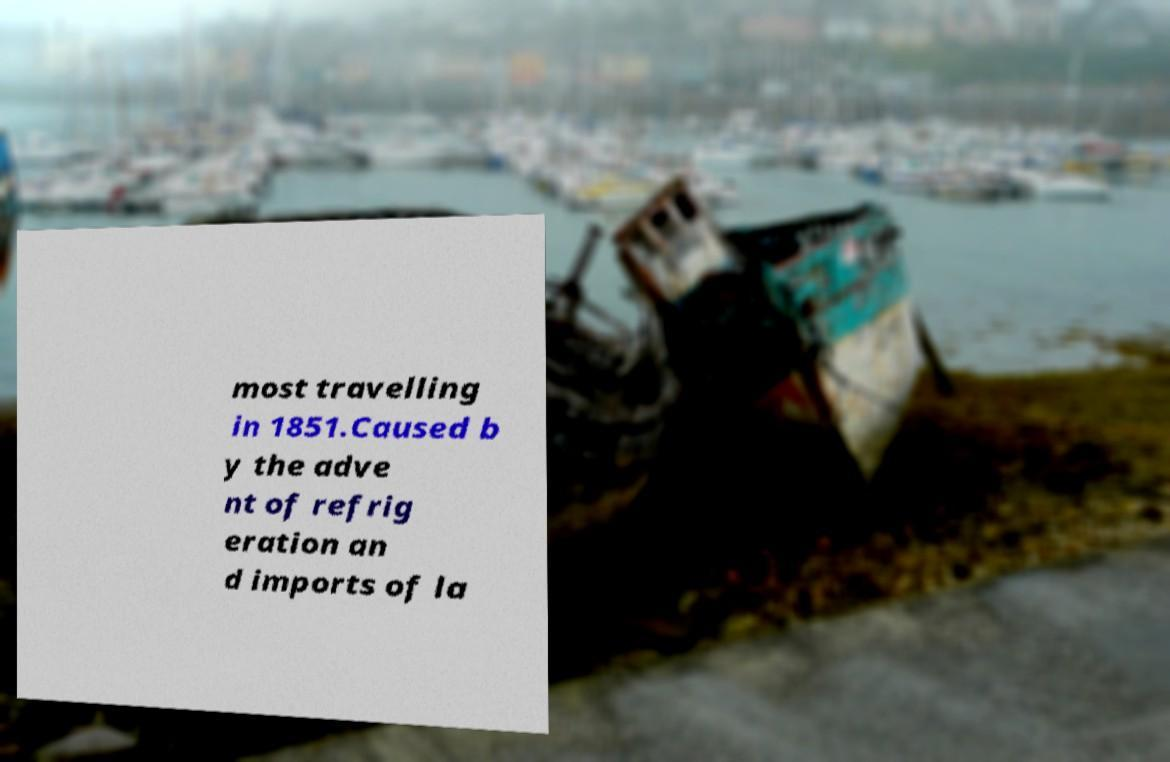Can you accurately transcribe the text from the provided image for me? most travelling in 1851.Caused b y the adve nt of refrig eration an d imports of la 